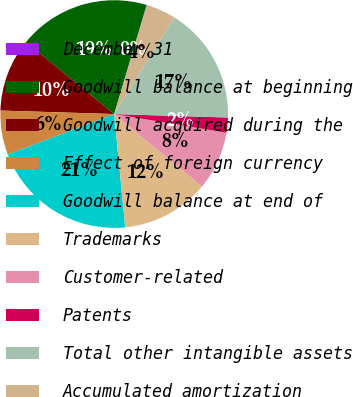Convert chart. <chart><loc_0><loc_0><loc_500><loc_500><pie_chart><fcel>December 31<fcel>Goodwill balance at beginning<fcel>Goodwill acquired during the<fcel>Effect of foreign currency<fcel>Goodwill balance at end of<fcel>Trademarks<fcel>Customer-related<fcel>Patents<fcel>Total other intangible assets<fcel>Accumulated amortization<nl><fcel>0.07%<fcel>18.69%<fcel>10.41%<fcel>6.28%<fcel>20.76%<fcel>12.48%<fcel>8.35%<fcel>2.14%<fcel>16.62%<fcel>4.21%<nl></chart> 